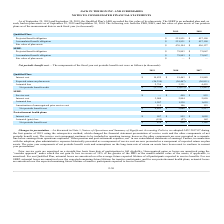According to Jack In The Box's financial document, How are prior service costs amortized? On a straight-line basis from date of participation to full eligibility. The document states: "Prior service costs are amortized on a straight-line basis from date of participation to full eligibility. Unrecognized gains or losses are amortized ..." Also, For SERP, how are actuarial losses amortized? Over the expected remaining future lifetime for inactive participants. The document states: "its. For our SERP, actuarial losses are amortized over the expected remaining future lifetime for inactive participants, and for our postretirement he..." Also, For SERP, what is the net periodic benefit cost for 2019? According to the financial document, $4,402 (in thousands). The relevant text states: "Net periodic benefit cost $ 4,402 $ 5,068 $ 5,517..." Also, can you calculate: For Qualified Plan, what is the difference in interest cost between 2018 and 2019? Based on the calculation: $19,825-$19,463, the result is 362 (in thousands). This is based on the information: "Interest cost $ 19,825 $ 19,463 $ 19,889 Interest cost $ 19,825 $ 19,463 $ 19,889..." The key data points involved are: 19,463, 19,825. Also, can you calculate: For SERP, what is the average actuarial loss for the years 2017-2019? To answer this question, I need to perform calculations using the financial data. The calculation is: (1,207+1,538+1,659)/3, which equals 1468 (in thousands). This is based on the information: "Actuarial loss 1,207 1,538 1,659 Actuarial loss 1,207 1,538 1,659 Actuarial loss 1,207 1,538 1,659..." The key data points involved are: 1,207, 1,538, 1,659. Also, can you calculate: For Postretirement health plans, what is the percentage constitution of interest cost among the net periodic benefit cost in 2017? Based on the calculation: 1,003/1,165, the result is 86.09 (percentage). This is based on the information: "Net periodic benefit cost $ 838 $ 928 $ 1,165 Interest cost $ 997 $ 955 $ 1,003..." The key data points involved are: 1,003, 1,165. 